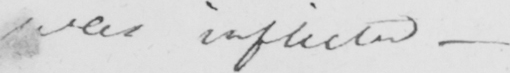Can you read and transcribe this handwriting? was inflicted  _ 